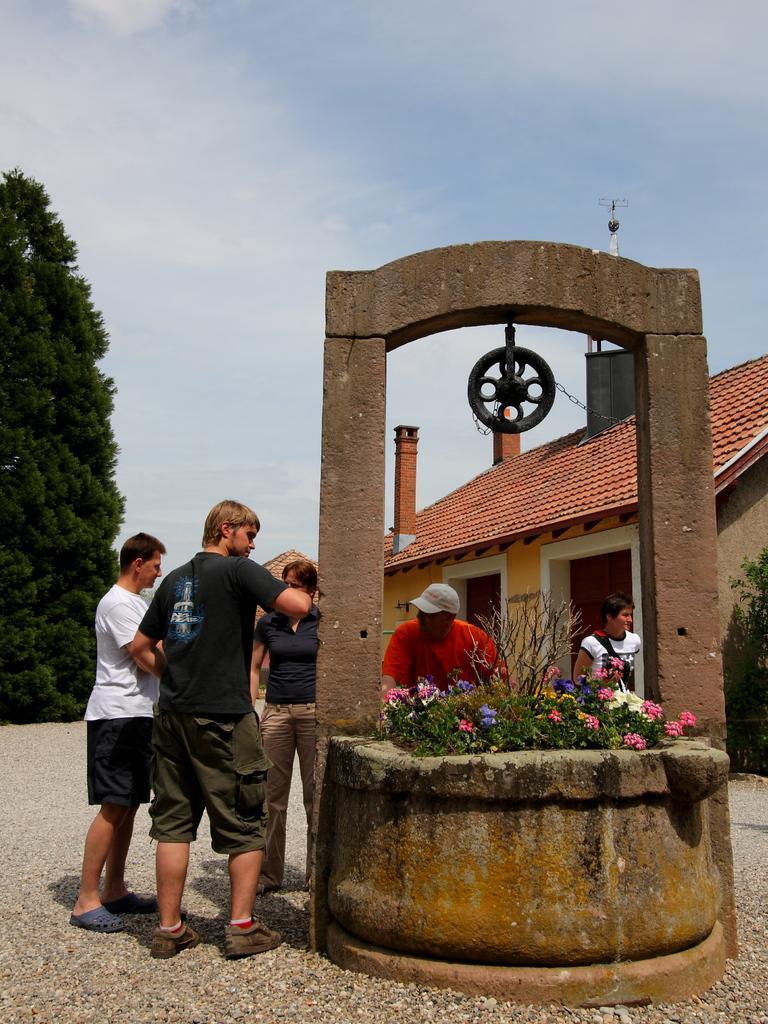Describe this image in one or two sentences. In this image, there are a few people. We can also see the ground. We can see some flowers in an object. We can also see a metallic object to the arch. We can see some houses. We can also see a plant and a tree. We can see the sky with clouds. 